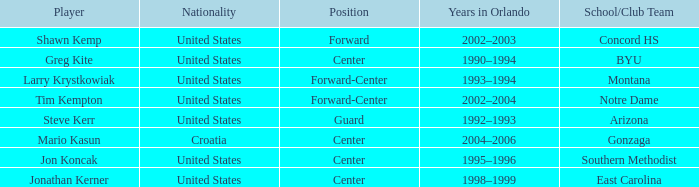What nationality has jon koncak as the player? United States. 